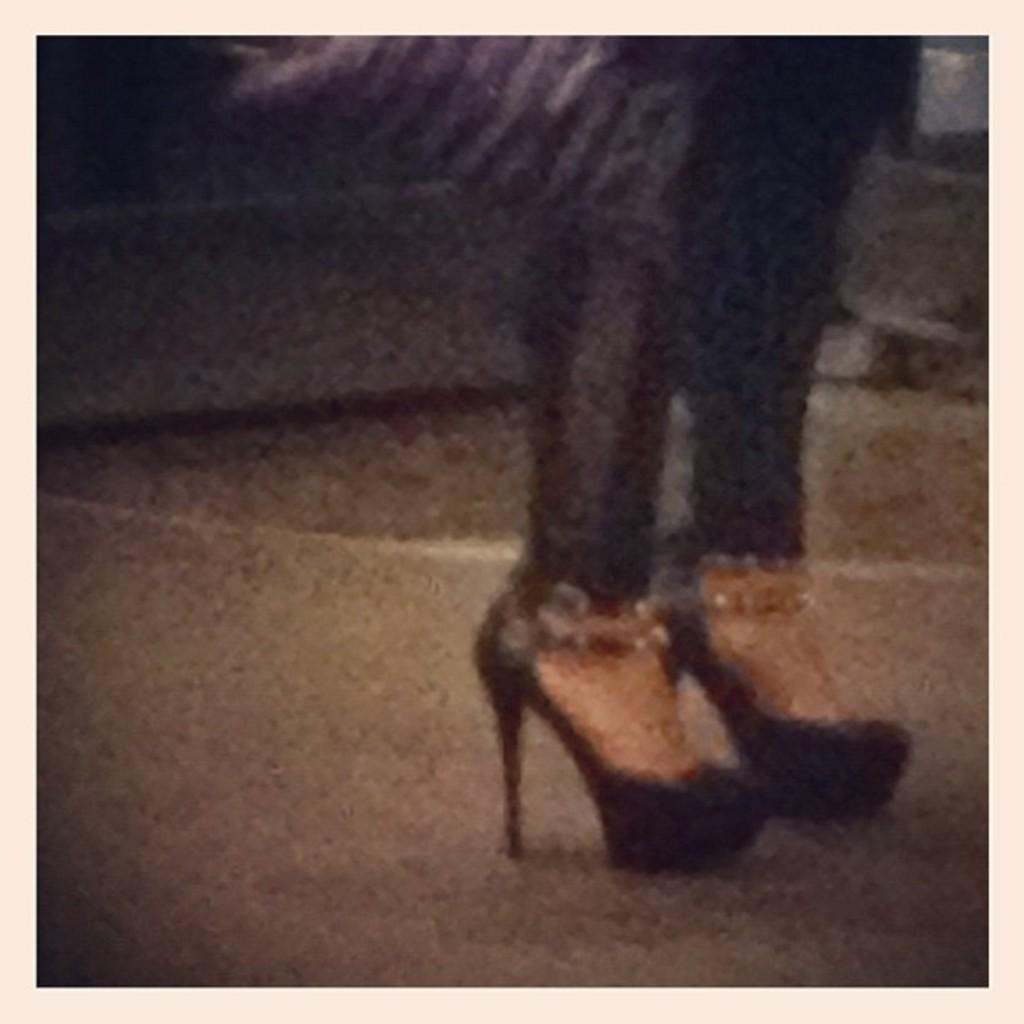Describe this image in one or two sentences. This image consists of a legs of a person. They are wearing shoes. 